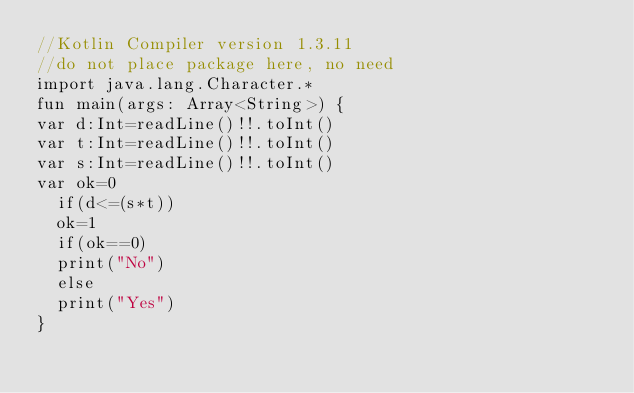<code> <loc_0><loc_0><loc_500><loc_500><_Kotlin_>//Kotlin Compiler version 1.3.11
//do not place package here, no need 
import java.lang.Character.*
fun main(args: Array<String>) {   
var d:Int=readLine()!!.toInt()
var t:Int=readLine()!!.toInt()  
var s:Int=readLine()!!.toInt()
var ok=0  
  if(d<=(s*t)) 
  ok=1 
  if(ok==0) 
  print("No") 
  else  
  print("Yes")
}</code> 